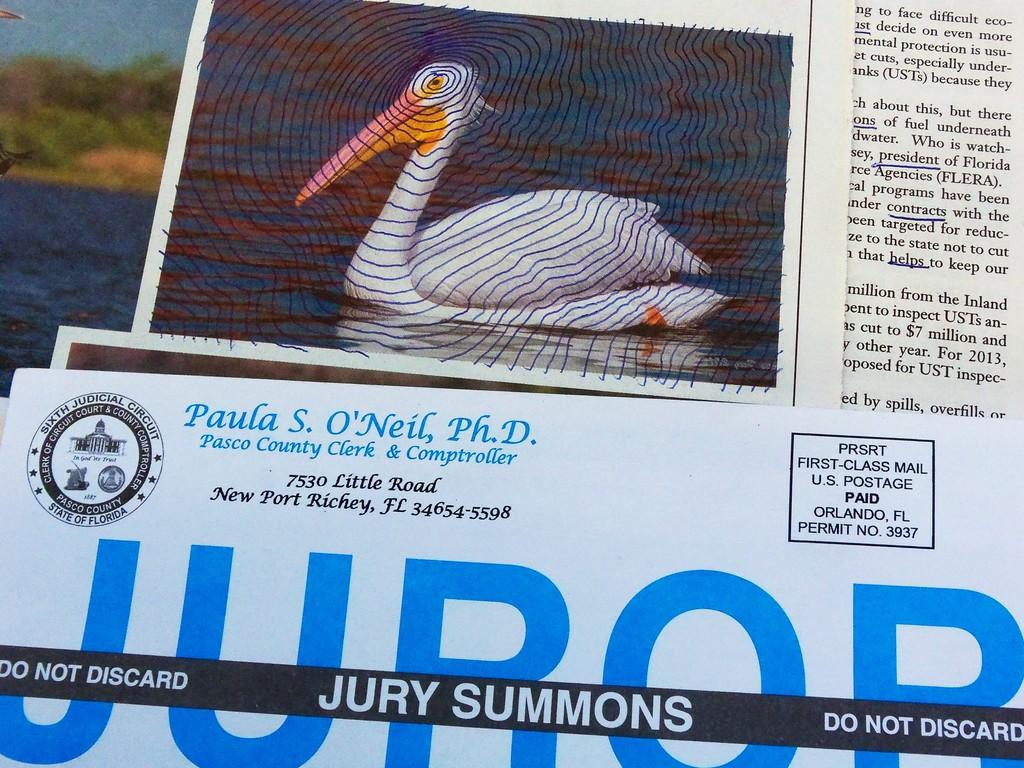What is the primary element visible in the image? There is water in the image. What type of vegetation can be seen in the image? There are trees in the image. What animal is present in the image? There is a swan in the image. Are there any words or letters in the image? Yes, there is text in the image. What treatment is the swan receiving in the image? There is no indication in the image that the swan is receiving any treatment. 